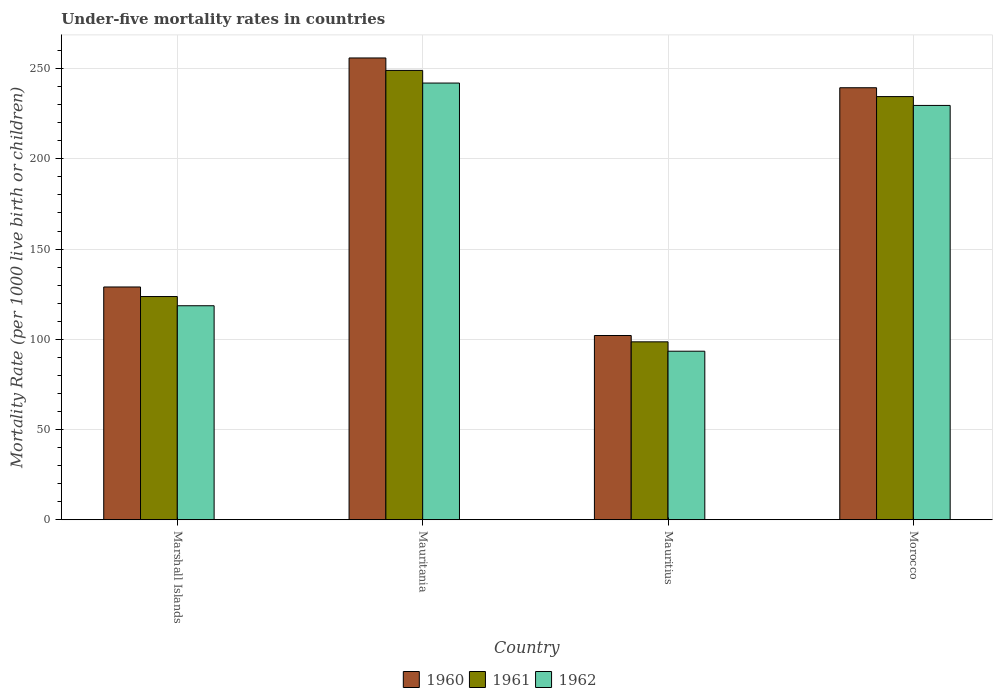How many different coloured bars are there?
Your answer should be very brief. 3. Are the number of bars per tick equal to the number of legend labels?
Your answer should be very brief. Yes. Are the number of bars on each tick of the X-axis equal?
Give a very brief answer. Yes. How many bars are there on the 1st tick from the left?
Your answer should be compact. 3. How many bars are there on the 3rd tick from the right?
Offer a terse response. 3. What is the label of the 3rd group of bars from the left?
Offer a very short reply. Mauritius. In how many cases, is the number of bars for a given country not equal to the number of legend labels?
Provide a succinct answer. 0. What is the under-five mortality rate in 1962 in Mauritius?
Provide a short and direct response. 93.4. Across all countries, what is the maximum under-five mortality rate in 1962?
Ensure brevity in your answer.  242. Across all countries, what is the minimum under-five mortality rate in 1961?
Make the answer very short. 98.6. In which country was the under-five mortality rate in 1961 maximum?
Ensure brevity in your answer.  Mauritania. In which country was the under-five mortality rate in 1961 minimum?
Your answer should be compact. Mauritius. What is the total under-five mortality rate in 1961 in the graph?
Offer a terse response. 705.8. What is the difference between the under-five mortality rate in 1961 in Marshall Islands and that in Mauritius?
Keep it short and to the point. 25.1. What is the difference between the under-five mortality rate in 1961 in Marshall Islands and the under-five mortality rate in 1960 in Morocco?
Your response must be concise. -115.7. What is the average under-five mortality rate in 1961 per country?
Your answer should be very brief. 176.45. What is the difference between the under-five mortality rate of/in 1960 and under-five mortality rate of/in 1962 in Marshall Islands?
Offer a terse response. 10.4. What is the ratio of the under-five mortality rate in 1961 in Marshall Islands to that in Morocco?
Offer a very short reply. 0.53. Is the under-five mortality rate in 1960 in Mauritius less than that in Morocco?
Give a very brief answer. Yes. Is the difference between the under-five mortality rate in 1960 in Marshall Islands and Mauritius greater than the difference between the under-five mortality rate in 1962 in Marshall Islands and Mauritius?
Your answer should be very brief. Yes. What is the difference between the highest and the second highest under-five mortality rate in 1961?
Offer a very short reply. 14.5. What is the difference between the highest and the lowest under-five mortality rate in 1960?
Your answer should be very brief. 153.8. Is the sum of the under-five mortality rate in 1960 in Marshall Islands and Morocco greater than the maximum under-five mortality rate in 1961 across all countries?
Your answer should be very brief. Yes. What does the 2nd bar from the right in Marshall Islands represents?
Provide a succinct answer. 1961. How many bars are there?
Ensure brevity in your answer.  12. How many countries are there in the graph?
Your answer should be compact. 4. Does the graph contain any zero values?
Make the answer very short. No. Does the graph contain grids?
Give a very brief answer. Yes. Where does the legend appear in the graph?
Your answer should be compact. Bottom center. How many legend labels are there?
Your response must be concise. 3. What is the title of the graph?
Your answer should be compact. Under-five mortality rates in countries. What is the label or title of the X-axis?
Make the answer very short. Country. What is the label or title of the Y-axis?
Provide a succinct answer. Mortality Rate (per 1000 live birth or children). What is the Mortality Rate (per 1000 live birth or children) of 1960 in Marshall Islands?
Ensure brevity in your answer.  129. What is the Mortality Rate (per 1000 live birth or children) in 1961 in Marshall Islands?
Your answer should be very brief. 123.7. What is the Mortality Rate (per 1000 live birth or children) in 1962 in Marshall Islands?
Your response must be concise. 118.6. What is the Mortality Rate (per 1000 live birth or children) in 1960 in Mauritania?
Keep it short and to the point. 255.9. What is the Mortality Rate (per 1000 live birth or children) of 1961 in Mauritania?
Your answer should be compact. 249. What is the Mortality Rate (per 1000 live birth or children) of 1962 in Mauritania?
Provide a succinct answer. 242. What is the Mortality Rate (per 1000 live birth or children) of 1960 in Mauritius?
Provide a succinct answer. 102.1. What is the Mortality Rate (per 1000 live birth or children) in 1961 in Mauritius?
Offer a very short reply. 98.6. What is the Mortality Rate (per 1000 live birth or children) of 1962 in Mauritius?
Keep it short and to the point. 93.4. What is the Mortality Rate (per 1000 live birth or children) of 1960 in Morocco?
Provide a short and direct response. 239.4. What is the Mortality Rate (per 1000 live birth or children) in 1961 in Morocco?
Make the answer very short. 234.5. What is the Mortality Rate (per 1000 live birth or children) in 1962 in Morocco?
Your answer should be compact. 229.6. Across all countries, what is the maximum Mortality Rate (per 1000 live birth or children) of 1960?
Give a very brief answer. 255.9. Across all countries, what is the maximum Mortality Rate (per 1000 live birth or children) in 1961?
Provide a short and direct response. 249. Across all countries, what is the maximum Mortality Rate (per 1000 live birth or children) of 1962?
Your response must be concise. 242. Across all countries, what is the minimum Mortality Rate (per 1000 live birth or children) of 1960?
Ensure brevity in your answer.  102.1. Across all countries, what is the minimum Mortality Rate (per 1000 live birth or children) in 1961?
Provide a succinct answer. 98.6. Across all countries, what is the minimum Mortality Rate (per 1000 live birth or children) of 1962?
Offer a very short reply. 93.4. What is the total Mortality Rate (per 1000 live birth or children) of 1960 in the graph?
Provide a succinct answer. 726.4. What is the total Mortality Rate (per 1000 live birth or children) of 1961 in the graph?
Provide a succinct answer. 705.8. What is the total Mortality Rate (per 1000 live birth or children) of 1962 in the graph?
Give a very brief answer. 683.6. What is the difference between the Mortality Rate (per 1000 live birth or children) of 1960 in Marshall Islands and that in Mauritania?
Ensure brevity in your answer.  -126.9. What is the difference between the Mortality Rate (per 1000 live birth or children) of 1961 in Marshall Islands and that in Mauritania?
Keep it short and to the point. -125.3. What is the difference between the Mortality Rate (per 1000 live birth or children) of 1962 in Marshall Islands and that in Mauritania?
Provide a short and direct response. -123.4. What is the difference between the Mortality Rate (per 1000 live birth or children) in 1960 in Marshall Islands and that in Mauritius?
Provide a short and direct response. 26.9. What is the difference between the Mortality Rate (per 1000 live birth or children) in 1961 in Marshall Islands and that in Mauritius?
Ensure brevity in your answer.  25.1. What is the difference between the Mortality Rate (per 1000 live birth or children) of 1962 in Marshall Islands and that in Mauritius?
Your answer should be very brief. 25.2. What is the difference between the Mortality Rate (per 1000 live birth or children) in 1960 in Marshall Islands and that in Morocco?
Keep it short and to the point. -110.4. What is the difference between the Mortality Rate (per 1000 live birth or children) of 1961 in Marshall Islands and that in Morocco?
Offer a terse response. -110.8. What is the difference between the Mortality Rate (per 1000 live birth or children) in 1962 in Marshall Islands and that in Morocco?
Give a very brief answer. -111. What is the difference between the Mortality Rate (per 1000 live birth or children) in 1960 in Mauritania and that in Mauritius?
Provide a short and direct response. 153.8. What is the difference between the Mortality Rate (per 1000 live birth or children) in 1961 in Mauritania and that in Mauritius?
Keep it short and to the point. 150.4. What is the difference between the Mortality Rate (per 1000 live birth or children) in 1962 in Mauritania and that in Mauritius?
Ensure brevity in your answer.  148.6. What is the difference between the Mortality Rate (per 1000 live birth or children) of 1962 in Mauritania and that in Morocco?
Make the answer very short. 12.4. What is the difference between the Mortality Rate (per 1000 live birth or children) in 1960 in Mauritius and that in Morocco?
Your answer should be very brief. -137.3. What is the difference between the Mortality Rate (per 1000 live birth or children) in 1961 in Mauritius and that in Morocco?
Your answer should be very brief. -135.9. What is the difference between the Mortality Rate (per 1000 live birth or children) of 1962 in Mauritius and that in Morocco?
Provide a short and direct response. -136.2. What is the difference between the Mortality Rate (per 1000 live birth or children) in 1960 in Marshall Islands and the Mortality Rate (per 1000 live birth or children) in 1961 in Mauritania?
Provide a short and direct response. -120. What is the difference between the Mortality Rate (per 1000 live birth or children) in 1960 in Marshall Islands and the Mortality Rate (per 1000 live birth or children) in 1962 in Mauritania?
Provide a succinct answer. -113. What is the difference between the Mortality Rate (per 1000 live birth or children) in 1961 in Marshall Islands and the Mortality Rate (per 1000 live birth or children) in 1962 in Mauritania?
Keep it short and to the point. -118.3. What is the difference between the Mortality Rate (per 1000 live birth or children) in 1960 in Marshall Islands and the Mortality Rate (per 1000 live birth or children) in 1961 in Mauritius?
Your answer should be compact. 30.4. What is the difference between the Mortality Rate (per 1000 live birth or children) in 1960 in Marshall Islands and the Mortality Rate (per 1000 live birth or children) in 1962 in Mauritius?
Your answer should be compact. 35.6. What is the difference between the Mortality Rate (per 1000 live birth or children) of 1961 in Marshall Islands and the Mortality Rate (per 1000 live birth or children) of 1962 in Mauritius?
Keep it short and to the point. 30.3. What is the difference between the Mortality Rate (per 1000 live birth or children) of 1960 in Marshall Islands and the Mortality Rate (per 1000 live birth or children) of 1961 in Morocco?
Provide a short and direct response. -105.5. What is the difference between the Mortality Rate (per 1000 live birth or children) in 1960 in Marshall Islands and the Mortality Rate (per 1000 live birth or children) in 1962 in Morocco?
Ensure brevity in your answer.  -100.6. What is the difference between the Mortality Rate (per 1000 live birth or children) in 1961 in Marshall Islands and the Mortality Rate (per 1000 live birth or children) in 1962 in Morocco?
Provide a short and direct response. -105.9. What is the difference between the Mortality Rate (per 1000 live birth or children) in 1960 in Mauritania and the Mortality Rate (per 1000 live birth or children) in 1961 in Mauritius?
Provide a short and direct response. 157.3. What is the difference between the Mortality Rate (per 1000 live birth or children) in 1960 in Mauritania and the Mortality Rate (per 1000 live birth or children) in 1962 in Mauritius?
Keep it short and to the point. 162.5. What is the difference between the Mortality Rate (per 1000 live birth or children) of 1961 in Mauritania and the Mortality Rate (per 1000 live birth or children) of 1962 in Mauritius?
Offer a terse response. 155.6. What is the difference between the Mortality Rate (per 1000 live birth or children) of 1960 in Mauritania and the Mortality Rate (per 1000 live birth or children) of 1961 in Morocco?
Offer a terse response. 21.4. What is the difference between the Mortality Rate (per 1000 live birth or children) of 1960 in Mauritania and the Mortality Rate (per 1000 live birth or children) of 1962 in Morocco?
Your answer should be very brief. 26.3. What is the difference between the Mortality Rate (per 1000 live birth or children) in 1961 in Mauritania and the Mortality Rate (per 1000 live birth or children) in 1962 in Morocco?
Make the answer very short. 19.4. What is the difference between the Mortality Rate (per 1000 live birth or children) in 1960 in Mauritius and the Mortality Rate (per 1000 live birth or children) in 1961 in Morocco?
Give a very brief answer. -132.4. What is the difference between the Mortality Rate (per 1000 live birth or children) of 1960 in Mauritius and the Mortality Rate (per 1000 live birth or children) of 1962 in Morocco?
Give a very brief answer. -127.5. What is the difference between the Mortality Rate (per 1000 live birth or children) of 1961 in Mauritius and the Mortality Rate (per 1000 live birth or children) of 1962 in Morocco?
Provide a succinct answer. -131. What is the average Mortality Rate (per 1000 live birth or children) in 1960 per country?
Your response must be concise. 181.6. What is the average Mortality Rate (per 1000 live birth or children) in 1961 per country?
Your response must be concise. 176.45. What is the average Mortality Rate (per 1000 live birth or children) in 1962 per country?
Offer a terse response. 170.9. What is the difference between the Mortality Rate (per 1000 live birth or children) in 1961 and Mortality Rate (per 1000 live birth or children) in 1962 in Marshall Islands?
Your answer should be compact. 5.1. What is the difference between the Mortality Rate (per 1000 live birth or children) in 1960 and Mortality Rate (per 1000 live birth or children) in 1961 in Mauritania?
Offer a terse response. 6.9. What is the difference between the Mortality Rate (per 1000 live birth or children) of 1960 and Mortality Rate (per 1000 live birth or children) of 1961 in Mauritius?
Provide a short and direct response. 3.5. What is the difference between the Mortality Rate (per 1000 live birth or children) of 1960 and Mortality Rate (per 1000 live birth or children) of 1962 in Mauritius?
Give a very brief answer. 8.7. What is the ratio of the Mortality Rate (per 1000 live birth or children) of 1960 in Marshall Islands to that in Mauritania?
Provide a short and direct response. 0.5. What is the ratio of the Mortality Rate (per 1000 live birth or children) in 1961 in Marshall Islands to that in Mauritania?
Keep it short and to the point. 0.5. What is the ratio of the Mortality Rate (per 1000 live birth or children) in 1962 in Marshall Islands to that in Mauritania?
Provide a succinct answer. 0.49. What is the ratio of the Mortality Rate (per 1000 live birth or children) of 1960 in Marshall Islands to that in Mauritius?
Your response must be concise. 1.26. What is the ratio of the Mortality Rate (per 1000 live birth or children) in 1961 in Marshall Islands to that in Mauritius?
Your response must be concise. 1.25. What is the ratio of the Mortality Rate (per 1000 live birth or children) in 1962 in Marshall Islands to that in Mauritius?
Keep it short and to the point. 1.27. What is the ratio of the Mortality Rate (per 1000 live birth or children) in 1960 in Marshall Islands to that in Morocco?
Offer a terse response. 0.54. What is the ratio of the Mortality Rate (per 1000 live birth or children) in 1961 in Marshall Islands to that in Morocco?
Provide a short and direct response. 0.53. What is the ratio of the Mortality Rate (per 1000 live birth or children) in 1962 in Marshall Islands to that in Morocco?
Your answer should be compact. 0.52. What is the ratio of the Mortality Rate (per 1000 live birth or children) in 1960 in Mauritania to that in Mauritius?
Give a very brief answer. 2.51. What is the ratio of the Mortality Rate (per 1000 live birth or children) in 1961 in Mauritania to that in Mauritius?
Ensure brevity in your answer.  2.53. What is the ratio of the Mortality Rate (per 1000 live birth or children) in 1962 in Mauritania to that in Mauritius?
Ensure brevity in your answer.  2.59. What is the ratio of the Mortality Rate (per 1000 live birth or children) of 1960 in Mauritania to that in Morocco?
Your response must be concise. 1.07. What is the ratio of the Mortality Rate (per 1000 live birth or children) of 1961 in Mauritania to that in Morocco?
Provide a short and direct response. 1.06. What is the ratio of the Mortality Rate (per 1000 live birth or children) of 1962 in Mauritania to that in Morocco?
Keep it short and to the point. 1.05. What is the ratio of the Mortality Rate (per 1000 live birth or children) in 1960 in Mauritius to that in Morocco?
Ensure brevity in your answer.  0.43. What is the ratio of the Mortality Rate (per 1000 live birth or children) in 1961 in Mauritius to that in Morocco?
Offer a very short reply. 0.42. What is the ratio of the Mortality Rate (per 1000 live birth or children) of 1962 in Mauritius to that in Morocco?
Provide a succinct answer. 0.41. What is the difference between the highest and the second highest Mortality Rate (per 1000 live birth or children) of 1960?
Keep it short and to the point. 16.5. What is the difference between the highest and the second highest Mortality Rate (per 1000 live birth or children) of 1962?
Give a very brief answer. 12.4. What is the difference between the highest and the lowest Mortality Rate (per 1000 live birth or children) in 1960?
Ensure brevity in your answer.  153.8. What is the difference between the highest and the lowest Mortality Rate (per 1000 live birth or children) in 1961?
Give a very brief answer. 150.4. What is the difference between the highest and the lowest Mortality Rate (per 1000 live birth or children) in 1962?
Offer a very short reply. 148.6. 